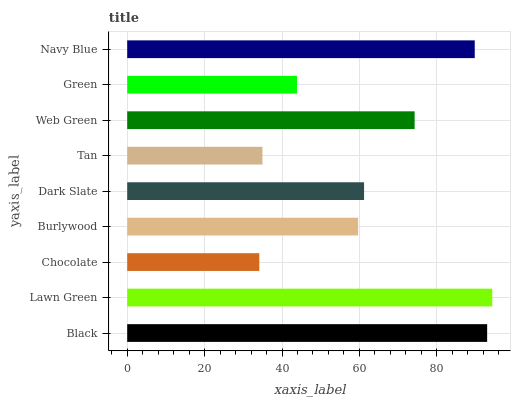Is Chocolate the minimum?
Answer yes or no. Yes. Is Lawn Green the maximum?
Answer yes or no. Yes. Is Lawn Green the minimum?
Answer yes or no. No. Is Chocolate the maximum?
Answer yes or no. No. Is Lawn Green greater than Chocolate?
Answer yes or no. Yes. Is Chocolate less than Lawn Green?
Answer yes or no. Yes. Is Chocolate greater than Lawn Green?
Answer yes or no. No. Is Lawn Green less than Chocolate?
Answer yes or no. No. Is Dark Slate the high median?
Answer yes or no. Yes. Is Dark Slate the low median?
Answer yes or no. Yes. Is Web Green the high median?
Answer yes or no. No. Is Chocolate the low median?
Answer yes or no. No. 